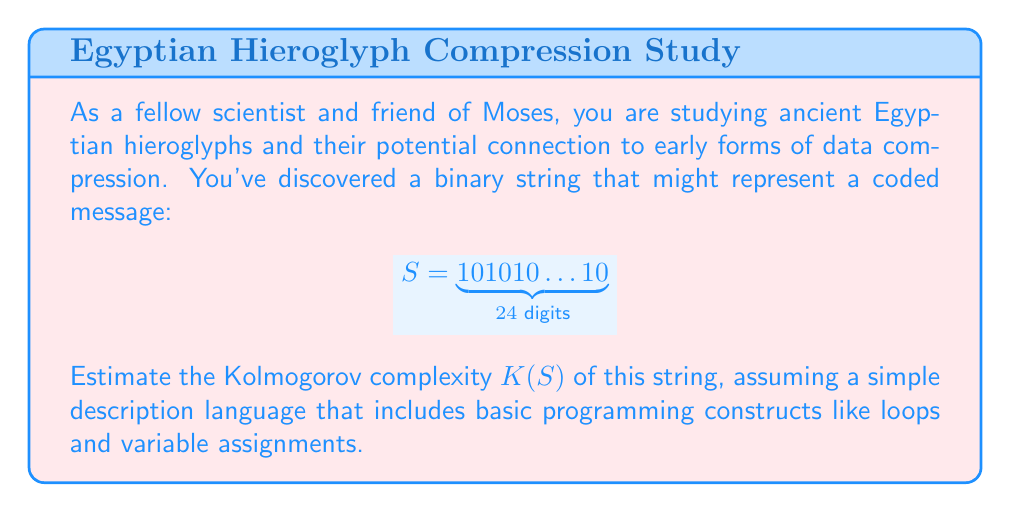Help me with this question. To estimate the Kolmogorov complexity $K(S)$ of the given binary string, we need to find a short program that can generate this string. Let's approach this step-by-step:

1. Observe the pattern: The string consists of alternating 1s and 0s, repeated 12 times.

2. We can describe this string using a simple loop structure:
   - Initialize a variable with '10'
   - Repeat this pattern 12 times

3. In pseudocode, this could be written as:
   ```
   x = '10'
   repeat 12 times:
     print x
   ```

4. To estimate the Kolmogorov complexity, we need to count the number of bits required to encode this program:
   - Assigning '10' to x: ~10 bits
   - Loop construct: ~10 bits
   - Number 12 (in binary): 8 bits
   - Print instruction: ~5 bits

5. Adding these up: $10 + 10 + 8 + 5 = 33$ bits

6. This is significantly shorter than the original string length of 24 bits.

7. The Kolmogorov complexity is bounded above by this program length, so we can estimate:

   $$K(S) \leq 33 \text{ bits}$$

8. Note that this is an upper bound; there might be even shorter programs to generate this string.
Answer: $K(S) \leq 33 \text{ bits}$ 